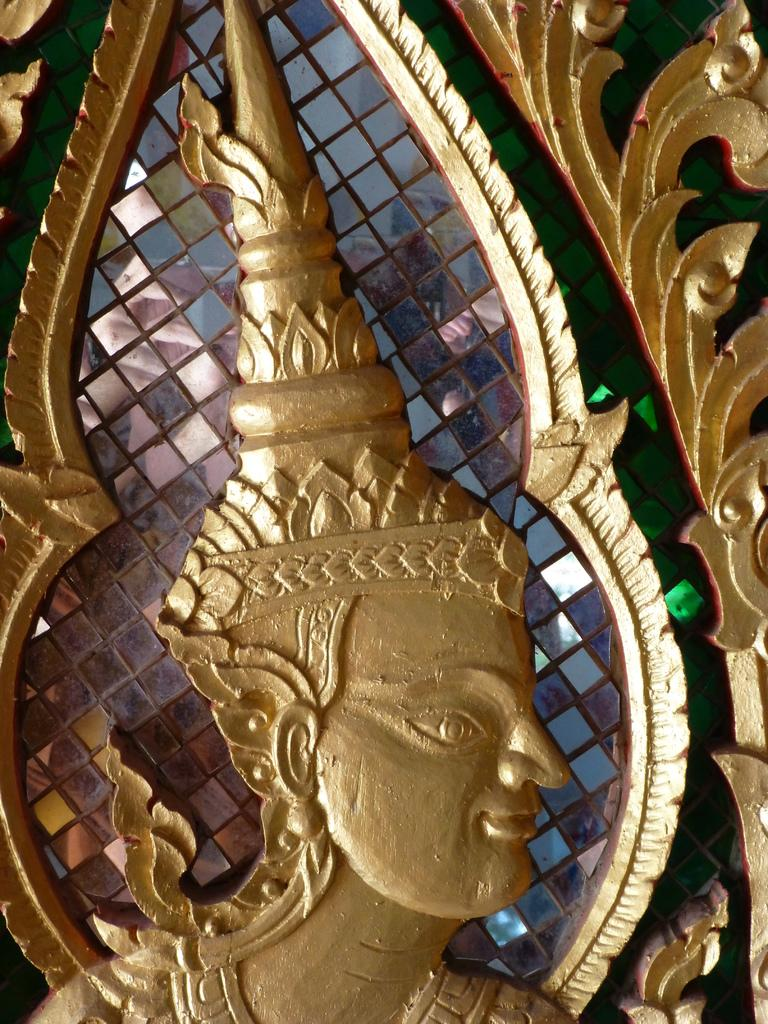What objects can be seen in the image? There are glasses and a statue in the image. Can you describe the statue in the image? Unfortunately, the provided facts do not give any details about the statue, so we cannot describe it. How many glasses are visible in the image? The provided facts do not specify the number of glasses, so we cannot determine the exact number. What type of engine is powering the pickle in the image? There is no pickle present in the image, so it is not possible to determine what type of engine might be powering it. 